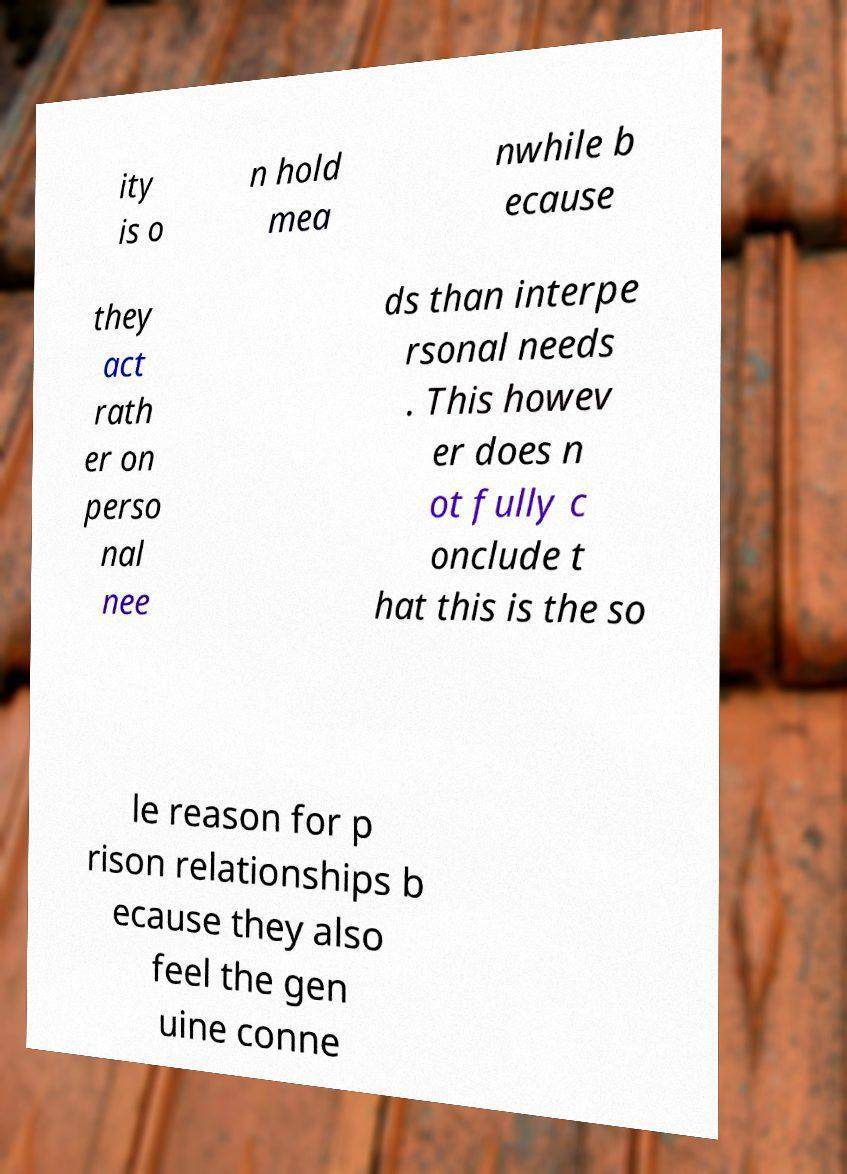Could you extract and type out the text from this image? ity is o n hold mea nwhile b ecause they act rath er on perso nal nee ds than interpe rsonal needs . This howev er does n ot fully c onclude t hat this is the so le reason for p rison relationships b ecause they also feel the gen uine conne 